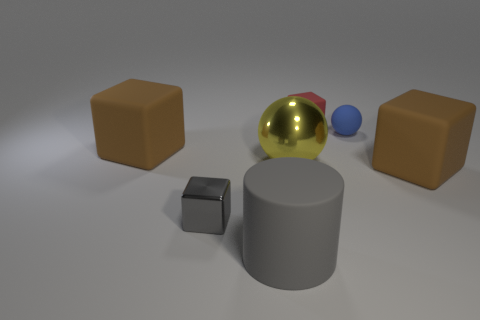Is the number of large brown rubber things to the right of the big rubber cylinder greater than the number of small red cubes?
Offer a terse response. No. Does the small blue thing have the same shape as the small gray metal thing?
Keep it short and to the point. No. How big is the gray metal cube?
Ensure brevity in your answer.  Small. Is the number of big metallic things that are to the right of the large gray rubber cylinder greater than the number of large brown rubber cubes behind the yellow metallic sphere?
Make the answer very short. No. There is a large yellow object; are there any big yellow things in front of it?
Your answer should be compact. No. Are there any blue rubber objects of the same size as the gray rubber cylinder?
Ensure brevity in your answer.  No. There is a small sphere that is the same material as the large cylinder; what is its color?
Your answer should be compact. Blue. What material is the blue sphere?
Your response must be concise. Rubber. What shape is the small blue matte object?
Make the answer very short. Sphere. What number of other things have the same color as the tiny shiny thing?
Offer a terse response. 1. 